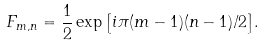Convert formula to latex. <formula><loc_0><loc_0><loc_500><loc_500>F _ { m , n } = \frac { 1 } { 2 } \exp { \left [ i \pi ( m - 1 ) ( n - 1 ) / 2 \right ] } .</formula> 